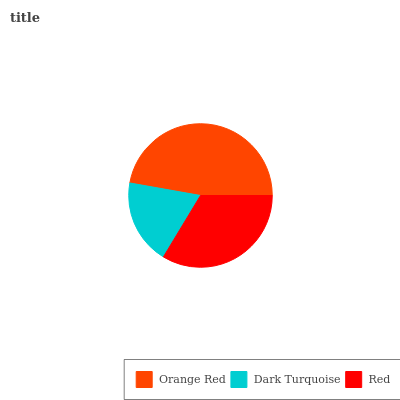Is Dark Turquoise the minimum?
Answer yes or no. Yes. Is Orange Red the maximum?
Answer yes or no. Yes. Is Red the minimum?
Answer yes or no. No. Is Red the maximum?
Answer yes or no. No. Is Red greater than Dark Turquoise?
Answer yes or no. Yes. Is Dark Turquoise less than Red?
Answer yes or no. Yes. Is Dark Turquoise greater than Red?
Answer yes or no. No. Is Red less than Dark Turquoise?
Answer yes or no. No. Is Red the high median?
Answer yes or no. Yes. Is Red the low median?
Answer yes or no. Yes. Is Dark Turquoise the high median?
Answer yes or no. No. Is Dark Turquoise the low median?
Answer yes or no. No. 